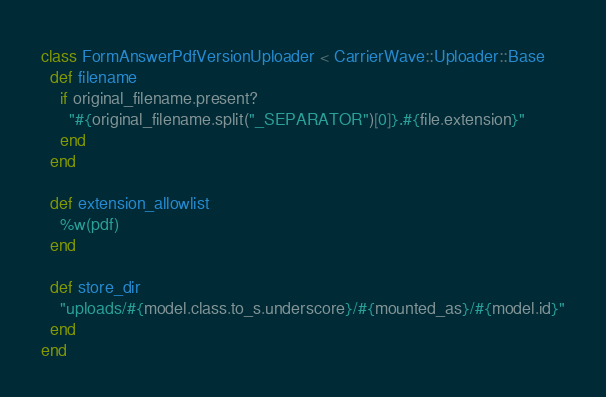Convert code to text. <code><loc_0><loc_0><loc_500><loc_500><_Ruby_>class FormAnswerPdfVersionUploader < CarrierWave::Uploader::Base
  def filename
    if original_filename.present?
      "#{original_filename.split("_SEPARATOR")[0]}.#{file.extension}"
    end
  end

  def extension_allowlist
    %w(pdf)
  end

  def store_dir
    "uploads/#{model.class.to_s.underscore}/#{mounted_as}/#{model.id}"
  end
end
</code> 